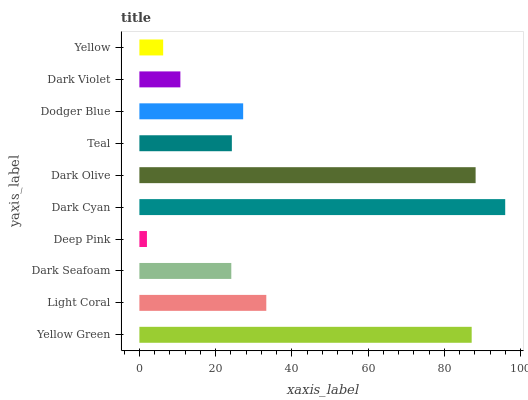Is Deep Pink the minimum?
Answer yes or no. Yes. Is Dark Cyan the maximum?
Answer yes or no. Yes. Is Light Coral the minimum?
Answer yes or no. No. Is Light Coral the maximum?
Answer yes or no. No. Is Yellow Green greater than Light Coral?
Answer yes or no. Yes. Is Light Coral less than Yellow Green?
Answer yes or no. Yes. Is Light Coral greater than Yellow Green?
Answer yes or no. No. Is Yellow Green less than Light Coral?
Answer yes or no. No. Is Dodger Blue the high median?
Answer yes or no. Yes. Is Teal the low median?
Answer yes or no. Yes. Is Teal the high median?
Answer yes or no. No. Is Dark Seafoam the low median?
Answer yes or no. No. 